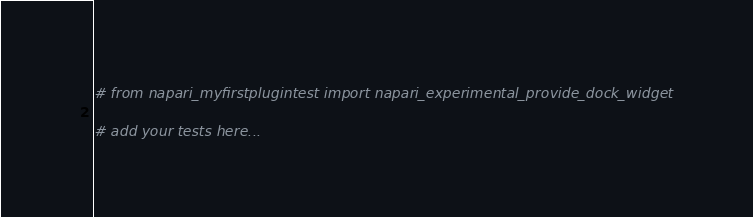Convert code to text. <code><loc_0><loc_0><loc_500><loc_500><_Python_># from napari_myfirstplugintest import napari_experimental_provide_dock_widget

# add your tests here...</code> 